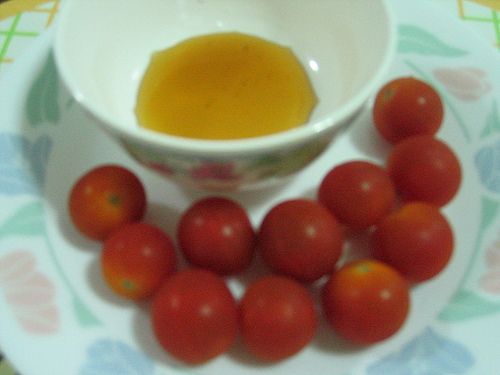<image>
Is the tea next to the tomato? Yes. The tea is positioned adjacent to the tomato, located nearby in the same general area. 